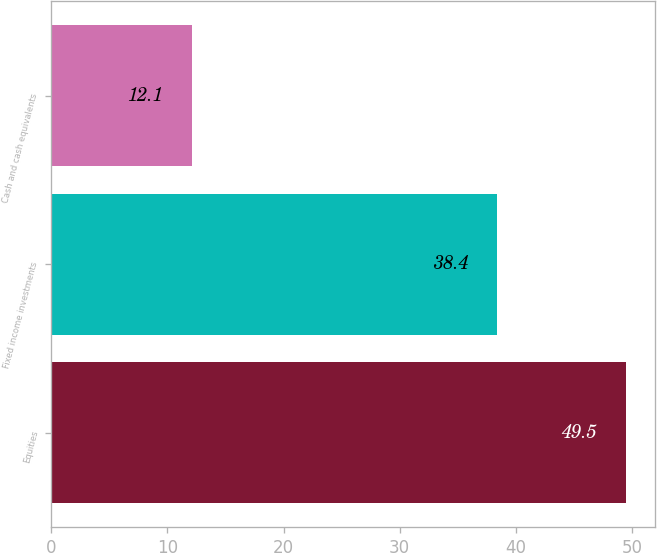<chart> <loc_0><loc_0><loc_500><loc_500><bar_chart><fcel>Equities<fcel>Fixed income investments<fcel>Cash and cash equivalents<nl><fcel>49.5<fcel>38.4<fcel>12.1<nl></chart> 